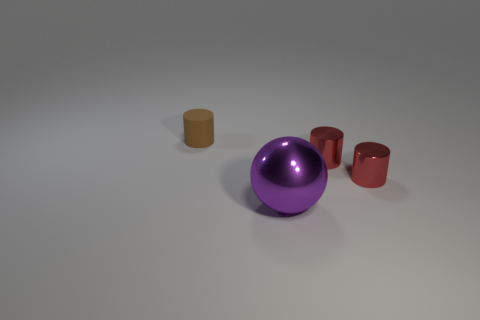Add 3 big purple metallic things. How many objects exist? 7 Subtract all cylinders. How many objects are left? 1 Subtract all tiny red objects. Subtract all brown cylinders. How many objects are left? 1 Add 4 small red metallic things. How many small red metallic things are left? 6 Add 4 tiny red cubes. How many tiny red cubes exist? 4 Subtract 1 brown cylinders. How many objects are left? 3 